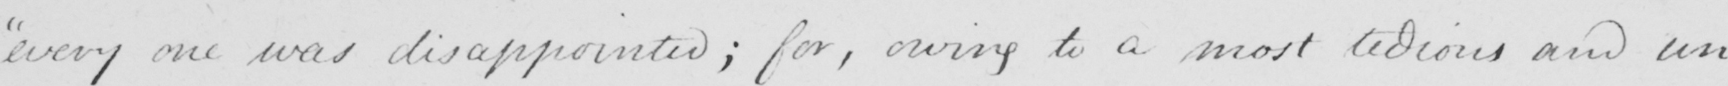What text is written in this handwritten line? every one was disappointed ; for , owing to a most tedious and un- 